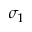Convert formula to latex. <formula><loc_0><loc_0><loc_500><loc_500>\sigma _ { 1 }</formula> 